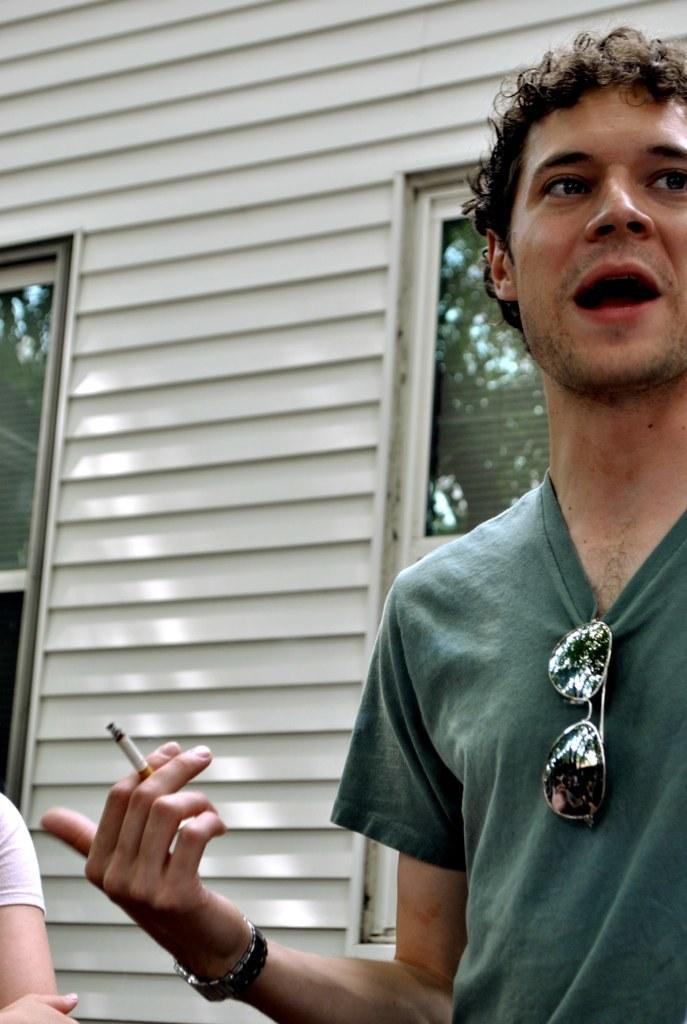Who or what is the main subject in the center of the image? There is a person in the center of the image. What is the person holding in his hand? The person is holding a cigar in his hand. What can be seen in the background of the image? There is a wall and a window in the background of the image. What type of statement is the person making in the image? There is no indication in the image that the person is making a statement, as there is no text or speech bubbles present. 